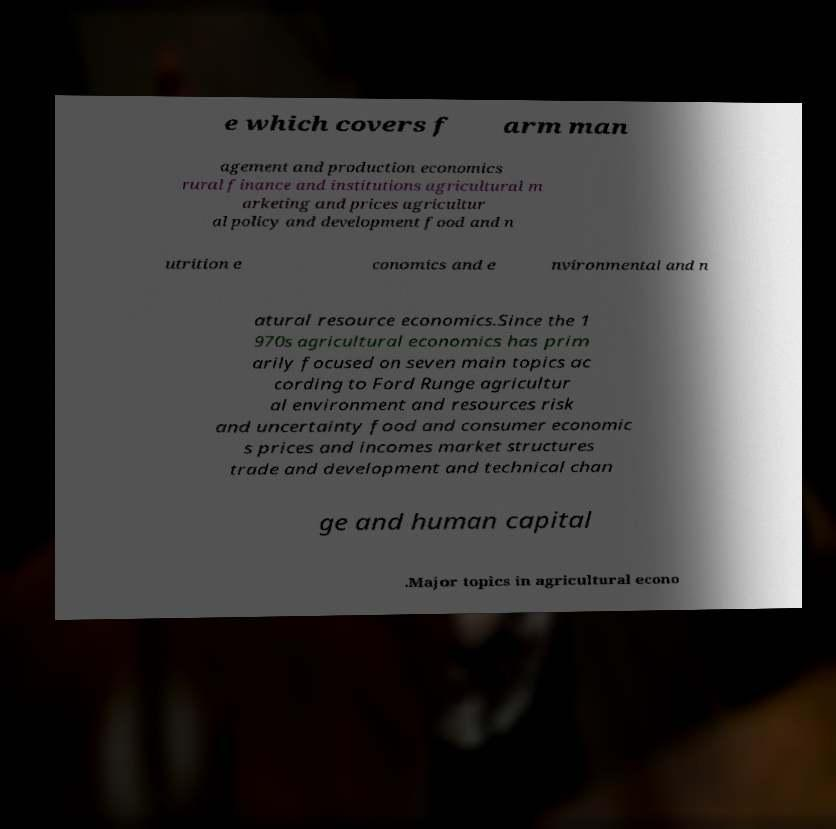Could you extract and type out the text from this image? e which covers f arm man agement and production economics rural finance and institutions agricultural m arketing and prices agricultur al policy and development food and n utrition e conomics and e nvironmental and n atural resource economics.Since the 1 970s agricultural economics has prim arily focused on seven main topics ac cording to Ford Runge agricultur al environment and resources risk and uncertainty food and consumer economic s prices and incomes market structures trade and development and technical chan ge and human capital .Major topics in agricultural econo 